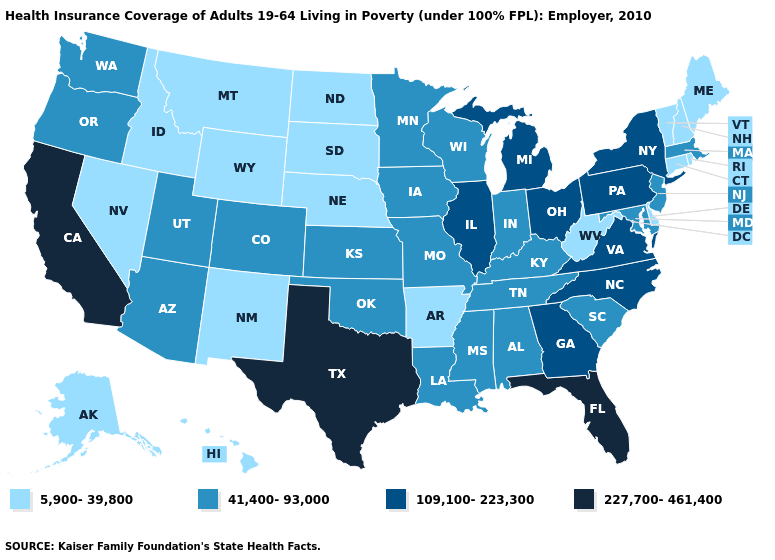Name the states that have a value in the range 5,900-39,800?
Answer briefly. Alaska, Arkansas, Connecticut, Delaware, Hawaii, Idaho, Maine, Montana, Nebraska, Nevada, New Hampshire, New Mexico, North Dakota, Rhode Island, South Dakota, Vermont, West Virginia, Wyoming. What is the highest value in states that border Arkansas?
Answer briefly. 227,700-461,400. Name the states that have a value in the range 5,900-39,800?
Short answer required. Alaska, Arkansas, Connecticut, Delaware, Hawaii, Idaho, Maine, Montana, Nebraska, Nevada, New Hampshire, New Mexico, North Dakota, Rhode Island, South Dakota, Vermont, West Virginia, Wyoming. Does Wyoming have a lower value than Kansas?
Concise answer only. Yes. Among the states that border Kansas , does Colorado have the highest value?
Answer briefly. Yes. Does North Dakota have the same value as Nebraska?
Be succinct. Yes. Does the first symbol in the legend represent the smallest category?
Quick response, please. Yes. What is the lowest value in the West?
Answer briefly. 5,900-39,800. What is the value of Louisiana?
Be succinct. 41,400-93,000. Name the states that have a value in the range 41,400-93,000?
Give a very brief answer. Alabama, Arizona, Colorado, Indiana, Iowa, Kansas, Kentucky, Louisiana, Maryland, Massachusetts, Minnesota, Mississippi, Missouri, New Jersey, Oklahoma, Oregon, South Carolina, Tennessee, Utah, Washington, Wisconsin. Does New Mexico have the lowest value in the USA?
Write a very short answer. Yes. Name the states that have a value in the range 41,400-93,000?
Give a very brief answer. Alabama, Arizona, Colorado, Indiana, Iowa, Kansas, Kentucky, Louisiana, Maryland, Massachusetts, Minnesota, Mississippi, Missouri, New Jersey, Oklahoma, Oregon, South Carolina, Tennessee, Utah, Washington, Wisconsin. Does the map have missing data?
Write a very short answer. No. Among the states that border Kansas , which have the lowest value?
Write a very short answer. Nebraska. Among the states that border Idaho , does Wyoming have the lowest value?
Short answer required. Yes. 